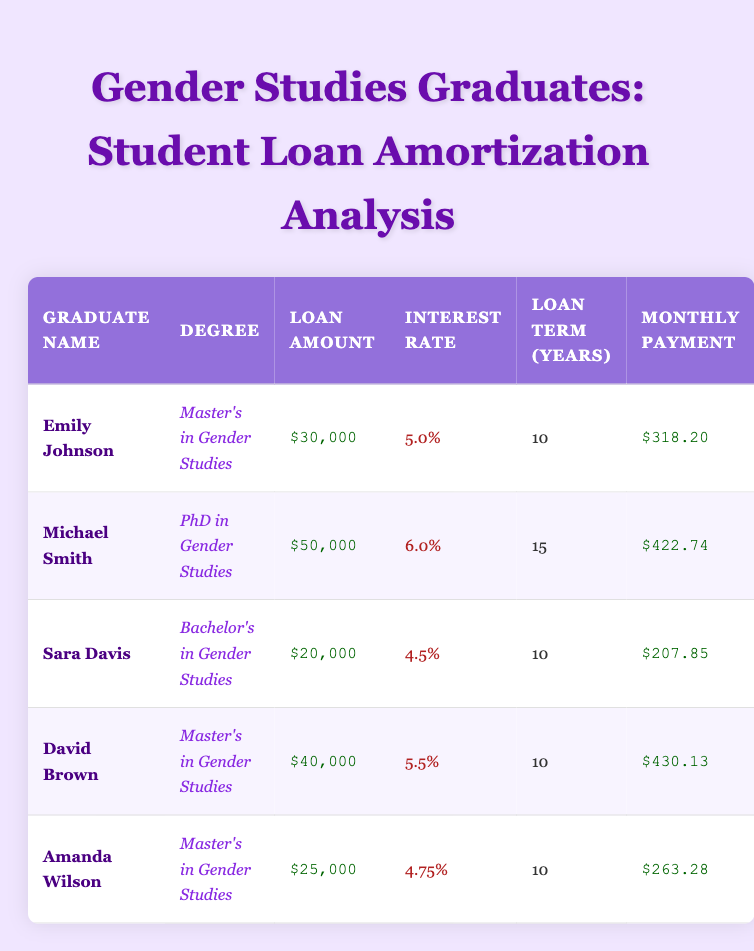What is the loan amount for Emily Johnson? In the table, under the "Loan Amount" column for Emily Johnson, the value is listed as $30,000.
Answer: $30,000 Who has the highest monthly payment among the graduates? The "Monthly Payment" column needs to be compared across all graduates. Michael Smith has a monthly payment of $422.74, which is higher than any other listed monthly payments.
Answer: Michael Smith Is Sara Davis's loan interest rate lower than Amanda Wilson's? By comparing the "Interest Rate" values for Sara Davis (4.5%) and Amanda Wilson (4.75%), it can be concluded that 4.5% is lower than 4.75%.
Answer: Yes What is the total loan amount for all graduates? Sum the loan amounts: $30,000 (Emily) + $50,000 (Michael) + $20,000 (Sara) + $40,000 (David) + $25,000 (Amanda) = $165,000.
Answer: $165,000 What is the average monthly payment for graduates with a Master's degree? The monthly payments for graduates with a Master's degree are $318.20 (Emily) + $430.13 (David) + $263.28 (Amanda), totaling $1,011. Dividing by the 3 graduates gives an average of $337.00.
Answer: $337.00 Does any graduate have a loan term longer than 10 years? Checking the "Loan Term (Years)" column, both Michael Smith and David Brown show terms of 15 years and 10 years respectively, confirming that at least one graduate does exceed 10 years.
Answer: Yes What combination of degree and interest rate applies to David Brown? The table indicates David Brown has a "Master's in Gender Studies," and his interest rate is listed as 5.5%.
Answer: Master's in Gender Studies, 5.5% Which gender studies graduate has the lowest monthly payment? Compare the monthly payments: Emily Johnson ($318.20), Michael Smith ($422.74), Sara Davis ($207.85), David Brown ($430.13), and Amanda Wilson ($263.28). The lowest among these is Sara Davis at $207.85.
Answer: Sara Davis What is the difference in loan amounts between Michael Smith and Amanda Wilson? The loan amount for Michael Smith is $50,000 and for Amanda Wilson is $25,000. The difference is $50,000 - $25,000 = $25,000.
Answer: $25,000 